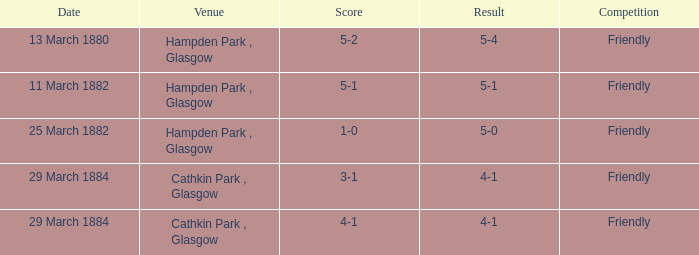In which contest was the outcome 4-1, with a scoreline of 4-1? Friendly. 